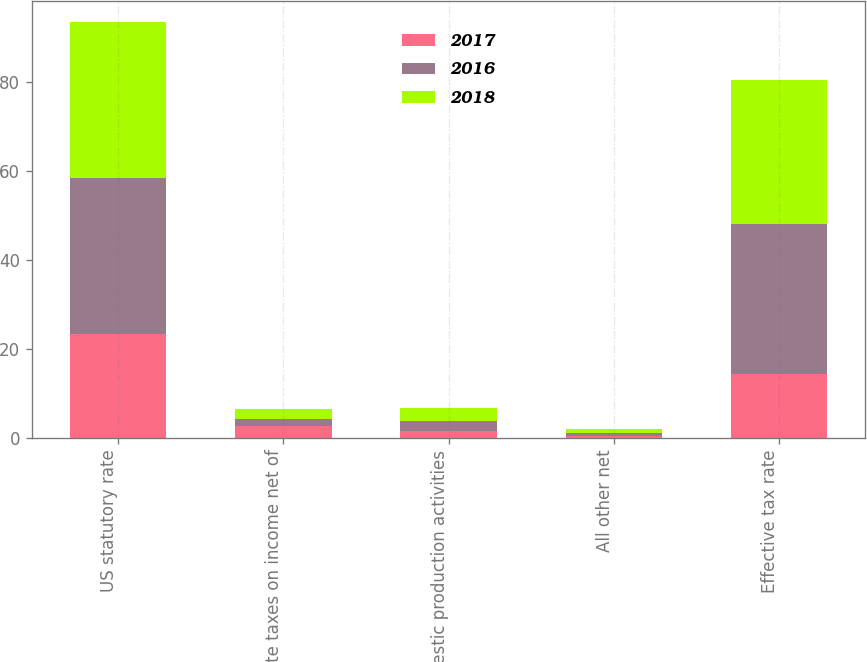Convert chart to OTSL. <chart><loc_0><loc_0><loc_500><loc_500><stacked_bar_chart><ecel><fcel>US statutory rate<fcel>State taxes on income net of<fcel>Domestic production activities<fcel>All other net<fcel>Effective tax rate<nl><fcel>2017<fcel>23.4<fcel>2.6<fcel>1.5<fcel>0.5<fcel>14.3<nl><fcel>2016<fcel>35<fcel>1.7<fcel>2.4<fcel>0.6<fcel>33.7<nl><fcel>2018<fcel>35<fcel>2.1<fcel>2.8<fcel>1<fcel>32.4<nl></chart> 